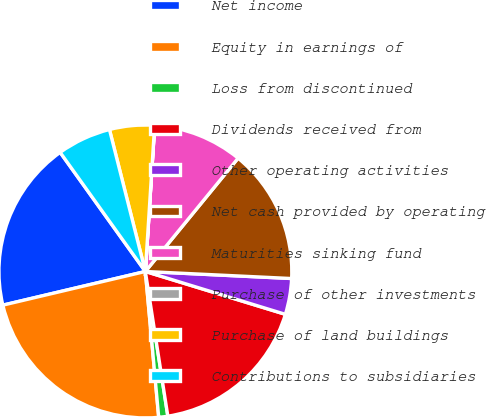<chart> <loc_0><loc_0><loc_500><loc_500><pie_chart><fcel>Net income<fcel>Equity in earnings of<fcel>Loss from discontinued<fcel>Dividends received from<fcel>Other operating activities<fcel>Net cash provided by operating<fcel>Maturities sinking fund<fcel>Purchase of other investments<fcel>Purchase of land buildings<fcel>Contributions to subsidiaries<nl><fcel>18.81%<fcel>22.76%<fcel>1.0%<fcel>17.82%<fcel>3.96%<fcel>14.85%<fcel>9.9%<fcel>0.01%<fcel>4.95%<fcel>5.94%<nl></chart> 